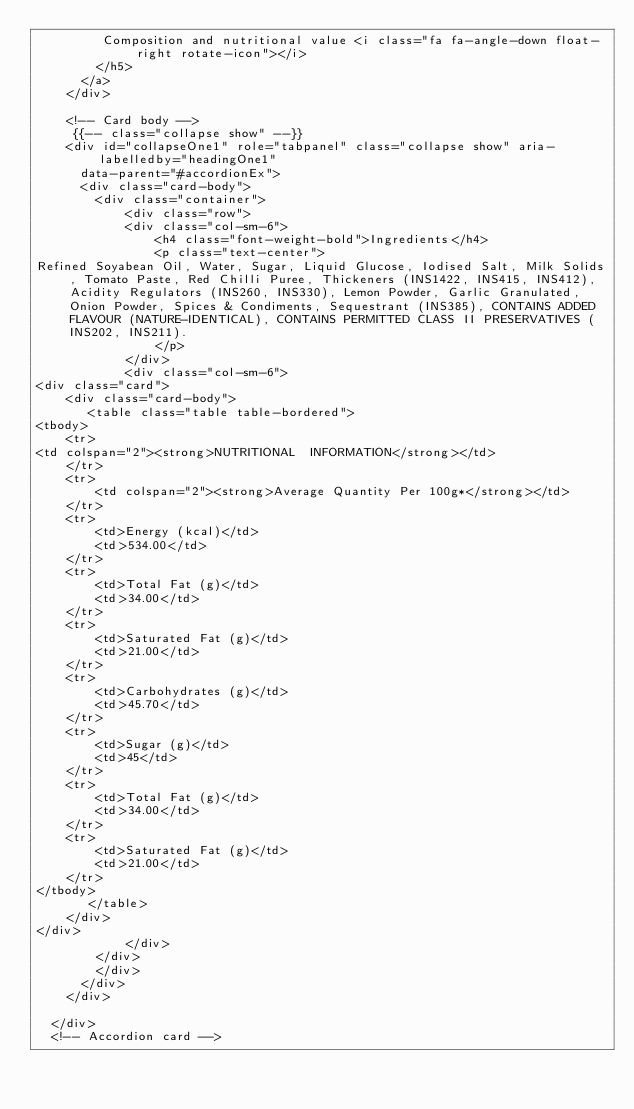Convert code to text. <code><loc_0><loc_0><loc_500><loc_500><_PHP_>         Composition and nutritional value <i class="fa fa-angle-down float-right rotate-icon"></i>
        </h5>
      </a>
    </div>

    <!-- Card body -->
     {{-- class="collapse show" --}}
    <div id="collapseOne1" role="tabpanel" class="collapse show" aria-labelledby="headingOne1"
      data-parent="#accordionEx">
      <div class="card-body">
        <div class="container">
            <div class="row">
            <div class="col-sm-6">
                <h4 class="font-weight-bold">Ingredients</h4>
                <p class="text-center">
Refined Soyabean Oil, Water, Sugar, Liquid Glucose, Iodised Salt, Milk Solids, Tomato Paste, Red Chilli Puree, Thickeners (INS1422, INS415, INS412), Acidity Regulators (INS260, INS330), Lemon Powder, Garlic Granulated, Onion Powder, Spices & Condiments, Sequestrant (INS385), CONTAINS ADDED FLAVOUR (NATURE-IDENTICAL), CONTAINS PERMITTED CLASS II PRESERVATIVES (INS202, INS211).
                </p>
            </div>
            <div class="col-sm-6">
<div class="card">
    <div class="card-body">
       <table class="table table-bordered">
<tbody>
    <tr>
<td colspan="2"><strong>NUTRITIONAL  INFORMATION</strong></td>
    </tr>
    <tr>
        <td colspan="2"><strong>Average Quantity Per 100g*</strong></td>
    </tr>
    <tr>
        <td>Energy (kcal)</td>
        <td>534.00</td>
    </tr>
    <tr>
        <td>Total Fat (g)</td>
        <td>34.00</td>
    </tr>
    <tr>
        <td>Saturated Fat (g)</td>
        <td>21.00</td>
    </tr>
    <tr>
        <td>Carbohydrates (g)</td>
        <td>45.70</td>
    </tr>
    <tr>
        <td>Sugar (g)</td>
        <td>45</td>
    </tr>
    <tr>
        <td>Total Fat (g)</td>
        <td>34.00</td>
    </tr>
    <tr>
        <td>Saturated Fat (g)</td>
        <td>21.00</td>
    </tr>
</tbody>
       </table>
    </div>
</div>
            </div>
        </div>
        </div>
      </div>
    </div>

  </div>
  <!-- Accordion card -->
</code> 